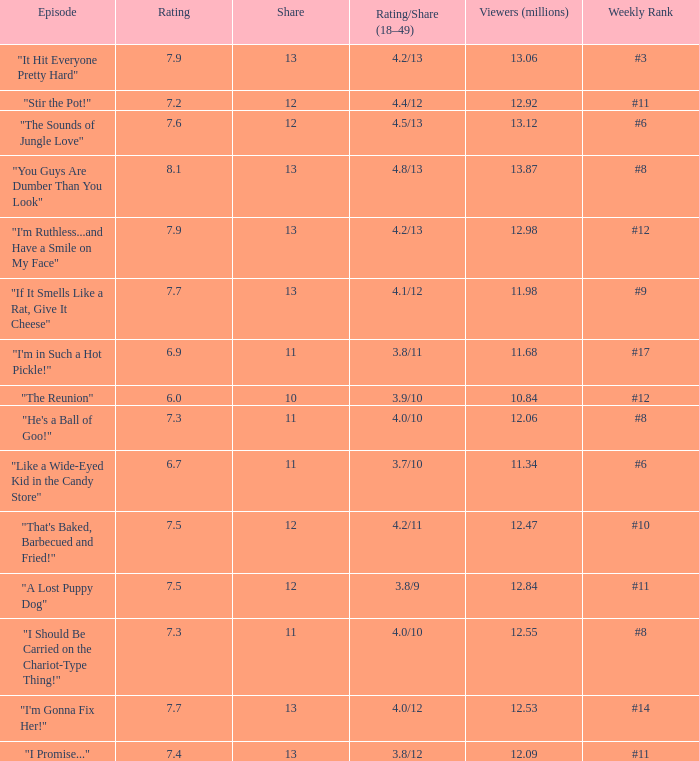What is the average rating for "a lost puppy dog"? 7.5. 